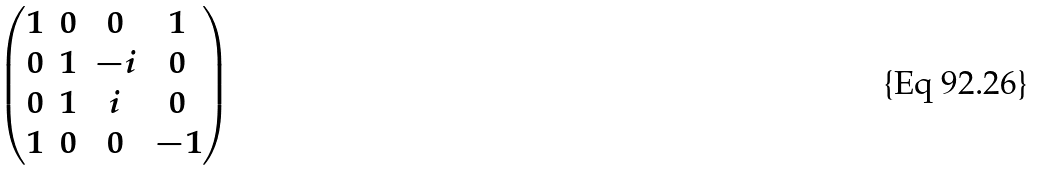<formula> <loc_0><loc_0><loc_500><loc_500>\begin{pmatrix} 1 & 0 & 0 & 1 \\ 0 & 1 & - i & 0 \\ 0 & 1 & i & 0 \\ 1 & 0 & 0 & - 1 \end{pmatrix}</formula> 